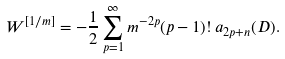Convert formula to latex. <formula><loc_0><loc_0><loc_500><loc_500>W ^ { [ 1 / m ] } = - \frac { 1 } { 2 } \sum _ { p = 1 } ^ { \infty } m ^ { - 2 p } ( p - 1 ) ! \, a _ { 2 p + n } ( D ) .</formula> 